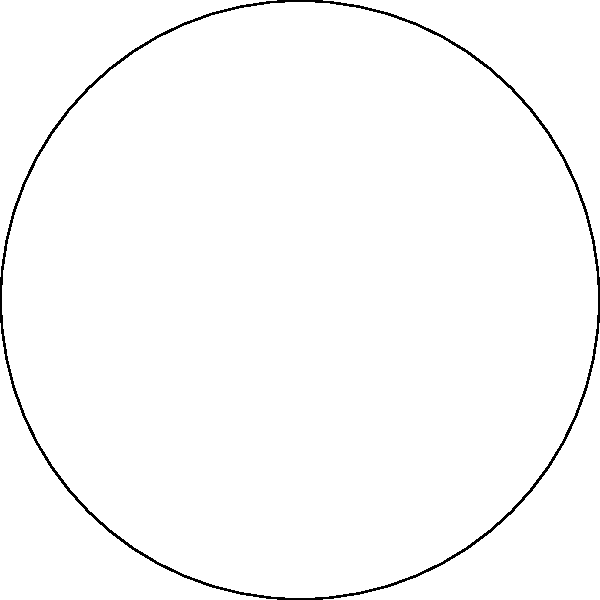In elliptic geometry, as shown in the figure above, consider two "lines" (great circles) on a sphere: the blue arc passing through points A, C, and D, and the red arc passing through B, C, and D. These arcs appear to intersect at two points. How does this observation challenge our understanding of parallel lines in Euclidean geometry, and what does it imply about the nature of parallel lines in elliptic geometry? To understand this concept, let's follow these steps:

1) In Euclidean geometry, parallel lines are defined as lines in the same plane that never intersect, no matter how far they are extended.

2) The figure shows a representation of an elliptic plane, which can be thought of as the surface of a sphere.

3) In elliptic geometry, "lines" are represented by great circles, which are the largest possible circles that can be drawn on the surface of a sphere.

4) The blue and red arcs in the figure represent two different "lines" in elliptic geometry.

5) We can observe that these two "lines" intersect at two points: C and D.

6) This is fundamentally different from Euclidean geometry, where two distinct lines can intersect at most once.

7) In fact, in elliptic geometry, any two distinct "lines" (great circles) will always intersect at exactly two points, which are antipodal points on the sphere.

8) This leads to a crucial conclusion: in elliptic geometry, there are no parallel lines. Every pair of distinct lines will always intersect.

9) This concept challenges our Euclidean understanding of parallel lines and demonstrates that the nature of geometry can change dramatically when we work on curved surfaces instead of flat planes.

10) The absence of parallel lines in elliptic geometry has profound implications for many geometric theorems and properties that rely on the concept of parallelism in Euclidean geometry.
Answer: In elliptic geometry, parallel lines do not exist; all lines (great circles) intersect. 